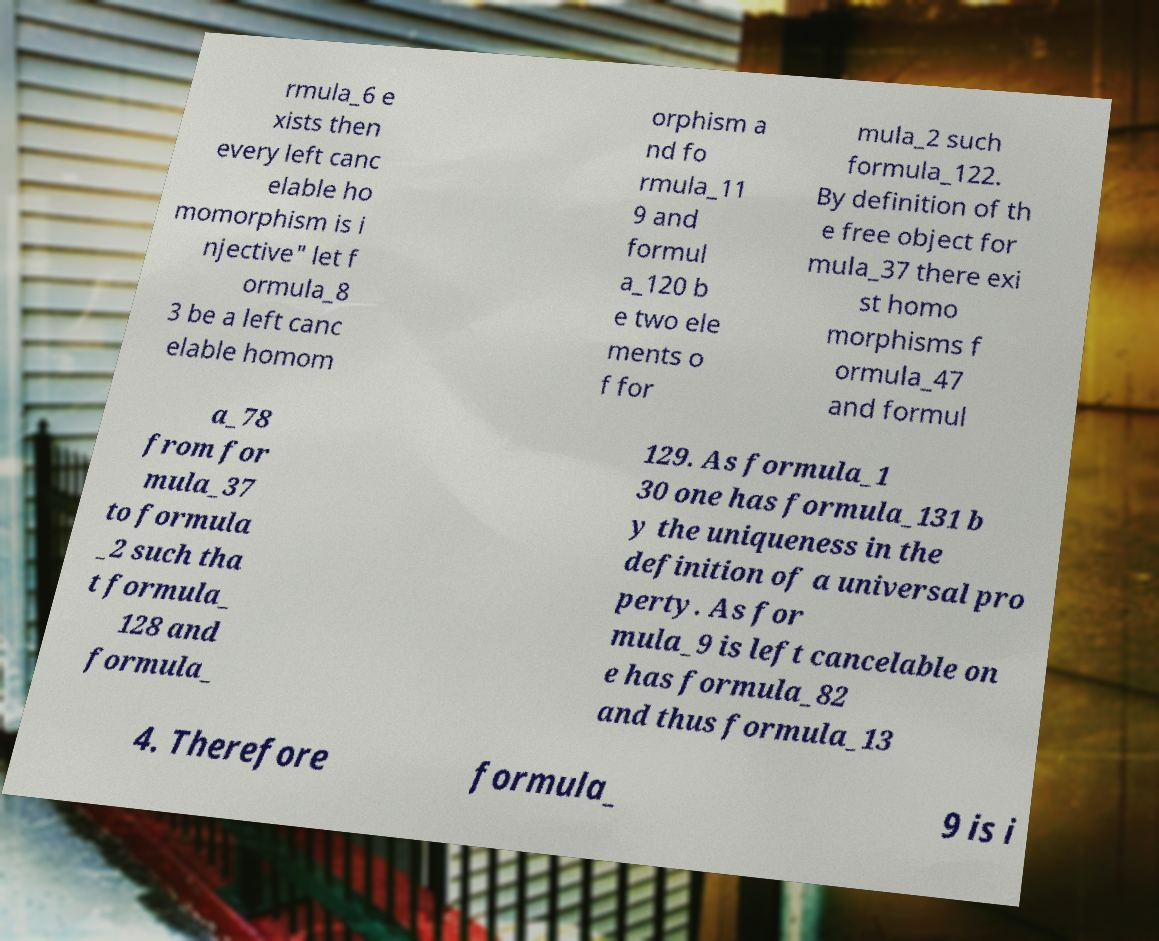Please identify and transcribe the text found in this image. rmula_6 e xists then every left canc elable ho momorphism is i njective" let f ormula_8 3 be a left canc elable homom orphism a nd fo rmula_11 9 and formul a_120 b e two ele ments o f for mula_2 such formula_122. By definition of th e free object for mula_37 there exi st homo morphisms f ormula_47 and formul a_78 from for mula_37 to formula _2 such tha t formula_ 128 and formula_ 129. As formula_1 30 one has formula_131 b y the uniqueness in the definition of a universal pro perty. As for mula_9 is left cancelable on e has formula_82 and thus formula_13 4. Therefore formula_ 9 is i 